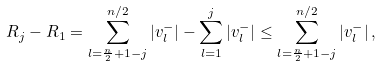Convert formula to latex. <formula><loc_0><loc_0><loc_500><loc_500>R _ { j } - R _ { 1 } = \sum _ { l = \frac { n } { 2 } + 1 - j } ^ { n / 2 } | v _ { l } ^ { - } | - \sum _ { l = 1 } ^ { j } | v _ { l } ^ { - } | \leq \sum _ { l = \frac { n } { 2 } + 1 - j } ^ { n / 2 } | v _ { l } ^ { - } | \, ,</formula> 